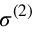<formula> <loc_0><loc_0><loc_500><loc_500>\sigma ^ { ( 2 ) }</formula> 